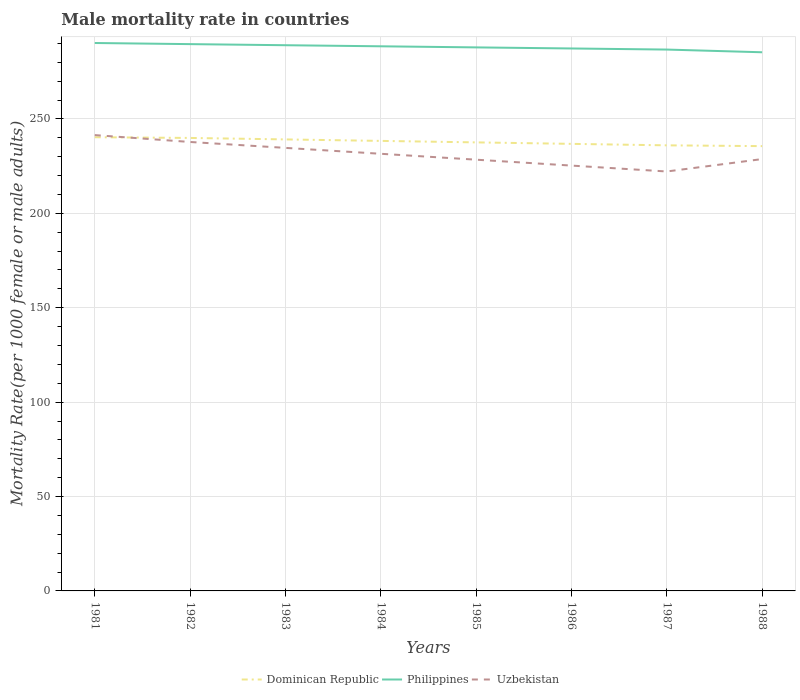How many different coloured lines are there?
Keep it short and to the point. 3. Is the number of lines equal to the number of legend labels?
Keep it short and to the point. Yes. Across all years, what is the maximum male mortality rate in Dominican Republic?
Provide a succinct answer. 235.6. What is the total male mortality rate in Dominican Republic in the graph?
Ensure brevity in your answer.  3.55. What is the difference between the highest and the second highest male mortality rate in Uzbekistan?
Provide a succinct answer. 19.28. Is the male mortality rate in Dominican Republic strictly greater than the male mortality rate in Uzbekistan over the years?
Ensure brevity in your answer.  No. How many lines are there?
Your answer should be very brief. 3. How many years are there in the graph?
Give a very brief answer. 8. Does the graph contain any zero values?
Keep it short and to the point. No. Does the graph contain grids?
Your response must be concise. Yes. How many legend labels are there?
Keep it short and to the point. 3. How are the legend labels stacked?
Your answer should be very brief. Horizontal. What is the title of the graph?
Give a very brief answer. Male mortality rate in countries. Does "Mauritania" appear as one of the legend labels in the graph?
Provide a short and direct response. No. What is the label or title of the X-axis?
Ensure brevity in your answer.  Years. What is the label or title of the Y-axis?
Offer a terse response. Mortality Rate(per 1000 female or male adults). What is the Mortality Rate(per 1000 female or male adults) in Dominican Republic in 1981?
Give a very brief answer. 240.32. What is the Mortality Rate(per 1000 female or male adults) of Philippines in 1981?
Provide a short and direct response. 290.23. What is the Mortality Rate(per 1000 female or male adults) in Uzbekistan in 1981?
Offer a very short reply. 241.45. What is the Mortality Rate(per 1000 female or male adults) in Dominican Republic in 1982?
Give a very brief answer. 239.94. What is the Mortality Rate(per 1000 female or male adults) of Philippines in 1982?
Offer a terse response. 289.63. What is the Mortality Rate(per 1000 female or male adults) of Uzbekistan in 1982?
Keep it short and to the point. 237.8. What is the Mortality Rate(per 1000 female or male adults) of Dominican Republic in 1983?
Offer a very short reply. 239.16. What is the Mortality Rate(per 1000 female or male adults) of Philippines in 1983?
Offer a very short reply. 289.06. What is the Mortality Rate(per 1000 female or male adults) in Uzbekistan in 1983?
Ensure brevity in your answer.  234.68. What is the Mortality Rate(per 1000 female or male adults) of Dominican Republic in 1984?
Give a very brief answer. 238.37. What is the Mortality Rate(per 1000 female or male adults) in Philippines in 1984?
Offer a very short reply. 288.48. What is the Mortality Rate(per 1000 female or male adults) of Uzbekistan in 1984?
Make the answer very short. 231.55. What is the Mortality Rate(per 1000 female or male adults) in Dominican Republic in 1985?
Your response must be concise. 237.59. What is the Mortality Rate(per 1000 female or male adults) in Philippines in 1985?
Give a very brief answer. 287.91. What is the Mortality Rate(per 1000 female or male adults) in Uzbekistan in 1985?
Provide a short and direct response. 228.42. What is the Mortality Rate(per 1000 female or male adults) in Dominican Republic in 1986?
Your answer should be very brief. 236.81. What is the Mortality Rate(per 1000 female or male adults) in Philippines in 1986?
Keep it short and to the point. 287.33. What is the Mortality Rate(per 1000 female or male adults) in Uzbekistan in 1986?
Offer a terse response. 225.3. What is the Mortality Rate(per 1000 female or male adults) of Dominican Republic in 1987?
Provide a short and direct response. 236.02. What is the Mortality Rate(per 1000 female or male adults) of Philippines in 1987?
Ensure brevity in your answer.  286.76. What is the Mortality Rate(per 1000 female or male adults) of Uzbekistan in 1987?
Your answer should be compact. 222.17. What is the Mortality Rate(per 1000 female or male adults) of Dominican Republic in 1988?
Your response must be concise. 235.6. What is the Mortality Rate(per 1000 female or male adults) of Philippines in 1988?
Provide a short and direct response. 285.32. What is the Mortality Rate(per 1000 female or male adults) of Uzbekistan in 1988?
Give a very brief answer. 228.75. Across all years, what is the maximum Mortality Rate(per 1000 female or male adults) of Dominican Republic?
Offer a terse response. 240.32. Across all years, what is the maximum Mortality Rate(per 1000 female or male adults) of Philippines?
Give a very brief answer. 290.23. Across all years, what is the maximum Mortality Rate(per 1000 female or male adults) of Uzbekistan?
Make the answer very short. 241.45. Across all years, what is the minimum Mortality Rate(per 1000 female or male adults) of Dominican Republic?
Offer a terse response. 235.6. Across all years, what is the minimum Mortality Rate(per 1000 female or male adults) of Philippines?
Your answer should be very brief. 285.32. Across all years, what is the minimum Mortality Rate(per 1000 female or male adults) in Uzbekistan?
Offer a terse response. 222.17. What is the total Mortality Rate(per 1000 female or male adults) in Dominican Republic in the graph?
Make the answer very short. 1903.81. What is the total Mortality Rate(per 1000 female or male adults) in Philippines in the graph?
Provide a succinct answer. 2304.71. What is the total Mortality Rate(per 1000 female or male adults) in Uzbekistan in the graph?
Keep it short and to the point. 1850.12. What is the difference between the Mortality Rate(per 1000 female or male adults) of Dominican Republic in 1981 and that in 1982?
Make the answer very short. 0.37. What is the difference between the Mortality Rate(per 1000 female or male adults) in Philippines in 1981 and that in 1982?
Your answer should be compact. 0.6. What is the difference between the Mortality Rate(per 1000 female or male adults) in Uzbekistan in 1981 and that in 1982?
Make the answer very short. 3.65. What is the difference between the Mortality Rate(per 1000 female or male adults) in Dominican Republic in 1981 and that in 1983?
Make the answer very short. 1.16. What is the difference between the Mortality Rate(per 1000 female or male adults) of Philippines in 1981 and that in 1983?
Provide a succinct answer. 1.17. What is the difference between the Mortality Rate(per 1000 female or male adults) in Uzbekistan in 1981 and that in 1983?
Offer a terse response. 6.77. What is the difference between the Mortality Rate(per 1000 female or male adults) of Dominican Republic in 1981 and that in 1984?
Keep it short and to the point. 1.94. What is the difference between the Mortality Rate(per 1000 female or male adults) of Philippines in 1981 and that in 1984?
Provide a short and direct response. 1.75. What is the difference between the Mortality Rate(per 1000 female or male adults) in Uzbekistan in 1981 and that in 1984?
Provide a succinct answer. 9.9. What is the difference between the Mortality Rate(per 1000 female or male adults) in Dominican Republic in 1981 and that in 1985?
Keep it short and to the point. 2.73. What is the difference between the Mortality Rate(per 1000 female or male adults) in Philippines in 1981 and that in 1985?
Give a very brief answer. 2.32. What is the difference between the Mortality Rate(per 1000 female or male adults) in Uzbekistan in 1981 and that in 1985?
Provide a short and direct response. 13.02. What is the difference between the Mortality Rate(per 1000 female or male adults) of Dominican Republic in 1981 and that in 1986?
Keep it short and to the point. 3.51. What is the difference between the Mortality Rate(per 1000 female or male adults) in Philippines in 1981 and that in 1986?
Your answer should be compact. 2.9. What is the difference between the Mortality Rate(per 1000 female or male adults) in Uzbekistan in 1981 and that in 1986?
Offer a very short reply. 16.15. What is the difference between the Mortality Rate(per 1000 female or male adults) of Dominican Republic in 1981 and that in 1987?
Make the answer very short. 4.29. What is the difference between the Mortality Rate(per 1000 female or male adults) in Philippines in 1981 and that in 1987?
Provide a succinct answer. 3.47. What is the difference between the Mortality Rate(per 1000 female or male adults) of Uzbekistan in 1981 and that in 1987?
Your answer should be compact. 19.27. What is the difference between the Mortality Rate(per 1000 female or male adults) in Dominican Republic in 1981 and that in 1988?
Your answer should be compact. 4.71. What is the difference between the Mortality Rate(per 1000 female or male adults) in Philippines in 1981 and that in 1988?
Offer a terse response. 4.91. What is the difference between the Mortality Rate(per 1000 female or male adults) in Uzbekistan in 1981 and that in 1988?
Your answer should be very brief. 12.7. What is the difference between the Mortality Rate(per 1000 female or male adults) in Dominican Republic in 1982 and that in 1983?
Your answer should be compact. 0.78. What is the difference between the Mortality Rate(per 1000 female or male adults) in Philippines in 1982 and that in 1983?
Offer a very short reply. 0.57. What is the difference between the Mortality Rate(per 1000 female or male adults) in Uzbekistan in 1982 and that in 1983?
Your answer should be very brief. 3.13. What is the difference between the Mortality Rate(per 1000 female or male adults) of Dominican Republic in 1982 and that in 1984?
Keep it short and to the point. 1.57. What is the difference between the Mortality Rate(per 1000 female or male adults) of Philippines in 1982 and that in 1984?
Your answer should be very brief. 1.15. What is the difference between the Mortality Rate(per 1000 female or male adults) of Uzbekistan in 1982 and that in 1984?
Make the answer very short. 6.25. What is the difference between the Mortality Rate(per 1000 female or male adults) in Dominican Republic in 1982 and that in 1985?
Make the answer very short. 2.35. What is the difference between the Mortality Rate(per 1000 female or male adults) of Philippines in 1982 and that in 1985?
Ensure brevity in your answer.  1.72. What is the difference between the Mortality Rate(per 1000 female or male adults) in Uzbekistan in 1982 and that in 1985?
Ensure brevity in your answer.  9.38. What is the difference between the Mortality Rate(per 1000 female or male adults) in Dominican Republic in 1982 and that in 1986?
Ensure brevity in your answer.  3.13. What is the difference between the Mortality Rate(per 1000 female or male adults) of Philippines in 1982 and that in 1986?
Keep it short and to the point. 2.3. What is the difference between the Mortality Rate(per 1000 female or male adults) of Uzbekistan in 1982 and that in 1986?
Keep it short and to the point. 12.5. What is the difference between the Mortality Rate(per 1000 female or male adults) in Dominican Republic in 1982 and that in 1987?
Give a very brief answer. 3.92. What is the difference between the Mortality Rate(per 1000 female or male adults) in Philippines in 1982 and that in 1987?
Offer a terse response. 2.87. What is the difference between the Mortality Rate(per 1000 female or male adults) in Uzbekistan in 1982 and that in 1987?
Your answer should be compact. 15.63. What is the difference between the Mortality Rate(per 1000 female or male adults) of Dominican Republic in 1982 and that in 1988?
Offer a terse response. 4.34. What is the difference between the Mortality Rate(per 1000 female or male adults) in Philippines in 1982 and that in 1988?
Give a very brief answer. 4.31. What is the difference between the Mortality Rate(per 1000 female or male adults) of Uzbekistan in 1982 and that in 1988?
Give a very brief answer. 9.05. What is the difference between the Mortality Rate(per 1000 female or male adults) in Dominican Republic in 1983 and that in 1984?
Make the answer very short. 0.78. What is the difference between the Mortality Rate(per 1000 female or male adults) of Philippines in 1983 and that in 1984?
Offer a terse response. 0.57. What is the difference between the Mortality Rate(per 1000 female or male adults) of Uzbekistan in 1983 and that in 1984?
Offer a very short reply. 3.13. What is the difference between the Mortality Rate(per 1000 female or male adults) of Dominican Republic in 1983 and that in 1985?
Ensure brevity in your answer.  1.57. What is the difference between the Mortality Rate(per 1000 female or male adults) in Philippines in 1983 and that in 1985?
Offer a terse response. 1.15. What is the difference between the Mortality Rate(per 1000 female or male adults) of Uzbekistan in 1983 and that in 1985?
Provide a succinct answer. 6.25. What is the difference between the Mortality Rate(per 1000 female or male adults) of Dominican Republic in 1983 and that in 1986?
Keep it short and to the point. 2.35. What is the difference between the Mortality Rate(per 1000 female or male adults) of Philippines in 1983 and that in 1986?
Provide a succinct answer. 1.72. What is the difference between the Mortality Rate(per 1000 female or male adults) in Uzbekistan in 1983 and that in 1986?
Your answer should be very brief. 9.38. What is the difference between the Mortality Rate(per 1000 female or male adults) of Dominican Republic in 1983 and that in 1987?
Keep it short and to the point. 3.13. What is the difference between the Mortality Rate(per 1000 female or male adults) in Philippines in 1983 and that in 1987?
Ensure brevity in your answer.  2.3. What is the difference between the Mortality Rate(per 1000 female or male adults) in Uzbekistan in 1983 and that in 1987?
Keep it short and to the point. 12.5. What is the difference between the Mortality Rate(per 1000 female or male adults) of Dominican Republic in 1983 and that in 1988?
Your response must be concise. 3.56. What is the difference between the Mortality Rate(per 1000 female or male adults) in Philippines in 1983 and that in 1988?
Provide a succinct answer. 3.74. What is the difference between the Mortality Rate(per 1000 female or male adults) of Uzbekistan in 1983 and that in 1988?
Your response must be concise. 5.93. What is the difference between the Mortality Rate(per 1000 female or male adults) of Dominican Republic in 1984 and that in 1985?
Provide a short and direct response. 0.78. What is the difference between the Mortality Rate(per 1000 female or male adults) of Philippines in 1984 and that in 1985?
Keep it short and to the point. 0.57. What is the difference between the Mortality Rate(per 1000 female or male adults) in Uzbekistan in 1984 and that in 1985?
Keep it short and to the point. 3.13. What is the difference between the Mortality Rate(per 1000 female or male adults) of Dominican Republic in 1984 and that in 1986?
Give a very brief answer. 1.57. What is the difference between the Mortality Rate(per 1000 female or male adults) in Philippines in 1984 and that in 1986?
Ensure brevity in your answer.  1.15. What is the difference between the Mortality Rate(per 1000 female or male adults) of Uzbekistan in 1984 and that in 1986?
Ensure brevity in your answer.  6.25. What is the difference between the Mortality Rate(per 1000 female or male adults) in Dominican Republic in 1984 and that in 1987?
Make the answer very short. 2.35. What is the difference between the Mortality Rate(per 1000 female or male adults) in Philippines in 1984 and that in 1987?
Make the answer very short. 1.72. What is the difference between the Mortality Rate(per 1000 female or male adults) of Uzbekistan in 1984 and that in 1987?
Keep it short and to the point. 9.38. What is the difference between the Mortality Rate(per 1000 female or male adults) of Dominican Republic in 1984 and that in 1988?
Give a very brief answer. 2.77. What is the difference between the Mortality Rate(per 1000 female or male adults) in Philippines in 1984 and that in 1988?
Provide a succinct answer. 3.16. What is the difference between the Mortality Rate(per 1000 female or male adults) in Uzbekistan in 1984 and that in 1988?
Offer a very short reply. 2.8. What is the difference between the Mortality Rate(per 1000 female or male adults) of Dominican Republic in 1985 and that in 1986?
Offer a very short reply. 0.78. What is the difference between the Mortality Rate(per 1000 female or male adults) in Philippines in 1985 and that in 1986?
Your answer should be very brief. 0.57. What is the difference between the Mortality Rate(per 1000 female or male adults) in Uzbekistan in 1985 and that in 1986?
Provide a succinct answer. 3.13. What is the difference between the Mortality Rate(per 1000 female or male adults) in Dominican Republic in 1985 and that in 1987?
Provide a succinct answer. 1.57. What is the difference between the Mortality Rate(per 1000 female or male adults) in Philippines in 1985 and that in 1987?
Offer a terse response. 1.15. What is the difference between the Mortality Rate(per 1000 female or male adults) in Uzbekistan in 1985 and that in 1987?
Offer a very short reply. 6.25. What is the difference between the Mortality Rate(per 1000 female or male adults) of Dominican Republic in 1985 and that in 1988?
Provide a short and direct response. 1.99. What is the difference between the Mortality Rate(per 1000 female or male adults) of Philippines in 1985 and that in 1988?
Your answer should be compact. 2.59. What is the difference between the Mortality Rate(per 1000 female or male adults) in Uzbekistan in 1985 and that in 1988?
Offer a very short reply. -0.32. What is the difference between the Mortality Rate(per 1000 female or male adults) in Dominican Republic in 1986 and that in 1987?
Your answer should be compact. 0.78. What is the difference between the Mortality Rate(per 1000 female or male adults) of Philippines in 1986 and that in 1987?
Provide a short and direct response. 0.57. What is the difference between the Mortality Rate(per 1000 female or male adults) of Uzbekistan in 1986 and that in 1987?
Keep it short and to the point. 3.13. What is the difference between the Mortality Rate(per 1000 female or male adults) in Dominican Republic in 1986 and that in 1988?
Ensure brevity in your answer.  1.2. What is the difference between the Mortality Rate(per 1000 female or male adults) of Philippines in 1986 and that in 1988?
Provide a succinct answer. 2.01. What is the difference between the Mortality Rate(per 1000 female or male adults) of Uzbekistan in 1986 and that in 1988?
Provide a short and direct response. -3.45. What is the difference between the Mortality Rate(per 1000 female or male adults) in Dominican Republic in 1987 and that in 1988?
Provide a succinct answer. 0.42. What is the difference between the Mortality Rate(per 1000 female or male adults) in Philippines in 1987 and that in 1988?
Provide a succinct answer. 1.44. What is the difference between the Mortality Rate(per 1000 female or male adults) of Uzbekistan in 1987 and that in 1988?
Your answer should be very brief. -6.58. What is the difference between the Mortality Rate(per 1000 female or male adults) in Dominican Republic in 1981 and the Mortality Rate(per 1000 female or male adults) in Philippines in 1982?
Offer a terse response. -49.31. What is the difference between the Mortality Rate(per 1000 female or male adults) in Dominican Republic in 1981 and the Mortality Rate(per 1000 female or male adults) in Uzbekistan in 1982?
Give a very brief answer. 2.51. What is the difference between the Mortality Rate(per 1000 female or male adults) in Philippines in 1981 and the Mortality Rate(per 1000 female or male adults) in Uzbekistan in 1982?
Your response must be concise. 52.43. What is the difference between the Mortality Rate(per 1000 female or male adults) of Dominican Republic in 1981 and the Mortality Rate(per 1000 female or male adults) of Philippines in 1983?
Offer a very short reply. -48.74. What is the difference between the Mortality Rate(per 1000 female or male adults) of Dominican Republic in 1981 and the Mortality Rate(per 1000 female or male adults) of Uzbekistan in 1983?
Your answer should be compact. 5.64. What is the difference between the Mortality Rate(per 1000 female or male adults) of Philippines in 1981 and the Mortality Rate(per 1000 female or male adults) of Uzbekistan in 1983?
Your response must be concise. 55.55. What is the difference between the Mortality Rate(per 1000 female or male adults) of Dominican Republic in 1981 and the Mortality Rate(per 1000 female or male adults) of Philippines in 1984?
Provide a short and direct response. -48.16. What is the difference between the Mortality Rate(per 1000 female or male adults) of Dominican Republic in 1981 and the Mortality Rate(per 1000 female or male adults) of Uzbekistan in 1984?
Give a very brief answer. 8.77. What is the difference between the Mortality Rate(per 1000 female or male adults) in Philippines in 1981 and the Mortality Rate(per 1000 female or male adults) in Uzbekistan in 1984?
Keep it short and to the point. 58.68. What is the difference between the Mortality Rate(per 1000 female or male adults) in Dominican Republic in 1981 and the Mortality Rate(per 1000 female or male adults) in Philippines in 1985?
Keep it short and to the point. -47.59. What is the difference between the Mortality Rate(per 1000 female or male adults) in Dominican Republic in 1981 and the Mortality Rate(per 1000 female or male adults) in Uzbekistan in 1985?
Your answer should be compact. 11.89. What is the difference between the Mortality Rate(per 1000 female or male adults) of Philippines in 1981 and the Mortality Rate(per 1000 female or male adults) of Uzbekistan in 1985?
Your answer should be compact. 61.81. What is the difference between the Mortality Rate(per 1000 female or male adults) of Dominican Republic in 1981 and the Mortality Rate(per 1000 female or male adults) of Philippines in 1986?
Give a very brief answer. -47.02. What is the difference between the Mortality Rate(per 1000 female or male adults) of Dominican Republic in 1981 and the Mortality Rate(per 1000 female or male adults) of Uzbekistan in 1986?
Keep it short and to the point. 15.02. What is the difference between the Mortality Rate(per 1000 female or male adults) of Philippines in 1981 and the Mortality Rate(per 1000 female or male adults) of Uzbekistan in 1986?
Your response must be concise. 64.93. What is the difference between the Mortality Rate(per 1000 female or male adults) of Dominican Republic in 1981 and the Mortality Rate(per 1000 female or male adults) of Philippines in 1987?
Your answer should be very brief. -46.44. What is the difference between the Mortality Rate(per 1000 female or male adults) of Dominican Republic in 1981 and the Mortality Rate(per 1000 female or male adults) of Uzbekistan in 1987?
Your response must be concise. 18.14. What is the difference between the Mortality Rate(per 1000 female or male adults) in Philippines in 1981 and the Mortality Rate(per 1000 female or male adults) in Uzbekistan in 1987?
Your answer should be very brief. 68.06. What is the difference between the Mortality Rate(per 1000 female or male adults) of Dominican Republic in 1981 and the Mortality Rate(per 1000 female or male adults) of Philippines in 1988?
Offer a terse response. -45. What is the difference between the Mortality Rate(per 1000 female or male adults) in Dominican Republic in 1981 and the Mortality Rate(per 1000 female or male adults) in Uzbekistan in 1988?
Provide a short and direct response. 11.57. What is the difference between the Mortality Rate(per 1000 female or male adults) of Philippines in 1981 and the Mortality Rate(per 1000 female or male adults) of Uzbekistan in 1988?
Your answer should be very brief. 61.48. What is the difference between the Mortality Rate(per 1000 female or male adults) of Dominican Republic in 1982 and the Mortality Rate(per 1000 female or male adults) of Philippines in 1983?
Your response must be concise. -49.11. What is the difference between the Mortality Rate(per 1000 female or male adults) in Dominican Republic in 1982 and the Mortality Rate(per 1000 female or male adults) in Uzbekistan in 1983?
Ensure brevity in your answer.  5.27. What is the difference between the Mortality Rate(per 1000 female or male adults) of Philippines in 1982 and the Mortality Rate(per 1000 female or male adults) of Uzbekistan in 1983?
Your answer should be very brief. 54.95. What is the difference between the Mortality Rate(per 1000 female or male adults) of Dominican Republic in 1982 and the Mortality Rate(per 1000 female or male adults) of Philippines in 1984?
Provide a succinct answer. -48.54. What is the difference between the Mortality Rate(per 1000 female or male adults) in Dominican Republic in 1982 and the Mortality Rate(per 1000 female or male adults) in Uzbekistan in 1984?
Ensure brevity in your answer.  8.39. What is the difference between the Mortality Rate(per 1000 female or male adults) of Philippines in 1982 and the Mortality Rate(per 1000 female or male adults) of Uzbekistan in 1984?
Provide a short and direct response. 58.08. What is the difference between the Mortality Rate(per 1000 female or male adults) of Dominican Republic in 1982 and the Mortality Rate(per 1000 female or male adults) of Philippines in 1985?
Offer a terse response. -47.97. What is the difference between the Mortality Rate(per 1000 female or male adults) in Dominican Republic in 1982 and the Mortality Rate(per 1000 female or male adults) in Uzbekistan in 1985?
Provide a short and direct response. 11.52. What is the difference between the Mortality Rate(per 1000 female or male adults) of Philippines in 1982 and the Mortality Rate(per 1000 female or male adults) of Uzbekistan in 1985?
Provide a short and direct response. 61.21. What is the difference between the Mortality Rate(per 1000 female or male adults) of Dominican Republic in 1982 and the Mortality Rate(per 1000 female or male adults) of Philippines in 1986?
Provide a short and direct response. -47.39. What is the difference between the Mortality Rate(per 1000 female or male adults) of Dominican Republic in 1982 and the Mortality Rate(per 1000 female or male adults) of Uzbekistan in 1986?
Your answer should be compact. 14.64. What is the difference between the Mortality Rate(per 1000 female or male adults) in Philippines in 1982 and the Mortality Rate(per 1000 female or male adults) in Uzbekistan in 1986?
Make the answer very short. 64.33. What is the difference between the Mortality Rate(per 1000 female or male adults) in Dominican Republic in 1982 and the Mortality Rate(per 1000 female or male adults) in Philippines in 1987?
Keep it short and to the point. -46.81. What is the difference between the Mortality Rate(per 1000 female or male adults) in Dominican Republic in 1982 and the Mortality Rate(per 1000 female or male adults) in Uzbekistan in 1987?
Offer a very short reply. 17.77. What is the difference between the Mortality Rate(per 1000 female or male adults) of Philippines in 1982 and the Mortality Rate(per 1000 female or male adults) of Uzbekistan in 1987?
Offer a very short reply. 67.46. What is the difference between the Mortality Rate(per 1000 female or male adults) of Dominican Republic in 1982 and the Mortality Rate(per 1000 female or male adults) of Philippines in 1988?
Your response must be concise. -45.38. What is the difference between the Mortality Rate(per 1000 female or male adults) of Dominican Republic in 1982 and the Mortality Rate(per 1000 female or male adults) of Uzbekistan in 1988?
Keep it short and to the point. 11.2. What is the difference between the Mortality Rate(per 1000 female or male adults) in Philippines in 1982 and the Mortality Rate(per 1000 female or male adults) in Uzbekistan in 1988?
Give a very brief answer. 60.88. What is the difference between the Mortality Rate(per 1000 female or male adults) of Dominican Republic in 1983 and the Mortality Rate(per 1000 female or male adults) of Philippines in 1984?
Offer a very short reply. -49.32. What is the difference between the Mortality Rate(per 1000 female or male adults) in Dominican Republic in 1983 and the Mortality Rate(per 1000 female or male adults) in Uzbekistan in 1984?
Your answer should be very brief. 7.61. What is the difference between the Mortality Rate(per 1000 female or male adults) of Philippines in 1983 and the Mortality Rate(per 1000 female or male adults) of Uzbekistan in 1984?
Offer a terse response. 57.51. What is the difference between the Mortality Rate(per 1000 female or male adults) of Dominican Republic in 1983 and the Mortality Rate(per 1000 female or male adults) of Philippines in 1985?
Your answer should be compact. -48.75. What is the difference between the Mortality Rate(per 1000 female or male adults) of Dominican Republic in 1983 and the Mortality Rate(per 1000 female or male adults) of Uzbekistan in 1985?
Provide a short and direct response. 10.73. What is the difference between the Mortality Rate(per 1000 female or male adults) of Philippines in 1983 and the Mortality Rate(per 1000 female or male adults) of Uzbekistan in 1985?
Provide a succinct answer. 60.63. What is the difference between the Mortality Rate(per 1000 female or male adults) of Dominican Republic in 1983 and the Mortality Rate(per 1000 female or male adults) of Philippines in 1986?
Your answer should be compact. -48.17. What is the difference between the Mortality Rate(per 1000 female or male adults) in Dominican Republic in 1983 and the Mortality Rate(per 1000 female or male adults) in Uzbekistan in 1986?
Give a very brief answer. 13.86. What is the difference between the Mortality Rate(per 1000 female or male adults) of Philippines in 1983 and the Mortality Rate(per 1000 female or male adults) of Uzbekistan in 1986?
Ensure brevity in your answer.  63.76. What is the difference between the Mortality Rate(per 1000 female or male adults) in Dominican Republic in 1983 and the Mortality Rate(per 1000 female or male adults) in Philippines in 1987?
Provide a succinct answer. -47.6. What is the difference between the Mortality Rate(per 1000 female or male adults) in Dominican Republic in 1983 and the Mortality Rate(per 1000 female or male adults) in Uzbekistan in 1987?
Your answer should be compact. 16.99. What is the difference between the Mortality Rate(per 1000 female or male adults) in Philippines in 1983 and the Mortality Rate(per 1000 female or male adults) in Uzbekistan in 1987?
Your answer should be very brief. 66.88. What is the difference between the Mortality Rate(per 1000 female or male adults) in Dominican Republic in 1983 and the Mortality Rate(per 1000 female or male adults) in Philippines in 1988?
Give a very brief answer. -46.16. What is the difference between the Mortality Rate(per 1000 female or male adults) of Dominican Republic in 1983 and the Mortality Rate(per 1000 female or male adults) of Uzbekistan in 1988?
Offer a terse response. 10.41. What is the difference between the Mortality Rate(per 1000 female or male adults) of Philippines in 1983 and the Mortality Rate(per 1000 female or male adults) of Uzbekistan in 1988?
Give a very brief answer. 60.31. What is the difference between the Mortality Rate(per 1000 female or male adults) in Dominican Republic in 1984 and the Mortality Rate(per 1000 female or male adults) in Philippines in 1985?
Ensure brevity in your answer.  -49.53. What is the difference between the Mortality Rate(per 1000 female or male adults) in Dominican Republic in 1984 and the Mortality Rate(per 1000 female or male adults) in Uzbekistan in 1985?
Keep it short and to the point. 9.95. What is the difference between the Mortality Rate(per 1000 female or male adults) in Philippines in 1984 and the Mortality Rate(per 1000 female or male adults) in Uzbekistan in 1985?
Make the answer very short. 60.06. What is the difference between the Mortality Rate(per 1000 female or male adults) in Dominican Republic in 1984 and the Mortality Rate(per 1000 female or male adults) in Philippines in 1986?
Your answer should be compact. -48.96. What is the difference between the Mortality Rate(per 1000 female or male adults) of Dominican Republic in 1984 and the Mortality Rate(per 1000 female or male adults) of Uzbekistan in 1986?
Offer a terse response. 13.08. What is the difference between the Mortality Rate(per 1000 female or male adults) of Philippines in 1984 and the Mortality Rate(per 1000 female or male adults) of Uzbekistan in 1986?
Keep it short and to the point. 63.18. What is the difference between the Mortality Rate(per 1000 female or male adults) in Dominican Republic in 1984 and the Mortality Rate(per 1000 female or male adults) in Philippines in 1987?
Make the answer very short. -48.38. What is the difference between the Mortality Rate(per 1000 female or male adults) of Dominican Republic in 1984 and the Mortality Rate(per 1000 female or male adults) of Uzbekistan in 1987?
Your answer should be very brief. 16.2. What is the difference between the Mortality Rate(per 1000 female or male adults) of Philippines in 1984 and the Mortality Rate(per 1000 female or male adults) of Uzbekistan in 1987?
Your answer should be compact. 66.31. What is the difference between the Mortality Rate(per 1000 female or male adults) in Dominican Republic in 1984 and the Mortality Rate(per 1000 female or male adults) in Philippines in 1988?
Provide a succinct answer. -46.94. What is the difference between the Mortality Rate(per 1000 female or male adults) of Dominican Republic in 1984 and the Mortality Rate(per 1000 female or male adults) of Uzbekistan in 1988?
Provide a short and direct response. 9.63. What is the difference between the Mortality Rate(per 1000 female or male adults) in Philippines in 1984 and the Mortality Rate(per 1000 female or male adults) in Uzbekistan in 1988?
Offer a very short reply. 59.73. What is the difference between the Mortality Rate(per 1000 female or male adults) of Dominican Republic in 1985 and the Mortality Rate(per 1000 female or male adults) of Philippines in 1986?
Your answer should be compact. -49.74. What is the difference between the Mortality Rate(per 1000 female or male adults) of Dominican Republic in 1985 and the Mortality Rate(per 1000 female or male adults) of Uzbekistan in 1986?
Make the answer very short. 12.29. What is the difference between the Mortality Rate(per 1000 female or male adults) of Philippines in 1985 and the Mortality Rate(per 1000 female or male adults) of Uzbekistan in 1986?
Give a very brief answer. 62.61. What is the difference between the Mortality Rate(per 1000 female or male adults) of Dominican Republic in 1985 and the Mortality Rate(per 1000 female or male adults) of Philippines in 1987?
Ensure brevity in your answer.  -49.17. What is the difference between the Mortality Rate(per 1000 female or male adults) of Dominican Republic in 1985 and the Mortality Rate(per 1000 female or male adults) of Uzbekistan in 1987?
Keep it short and to the point. 15.42. What is the difference between the Mortality Rate(per 1000 female or male adults) of Philippines in 1985 and the Mortality Rate(per 1000 female or male adults) of Uzbekistan in 1987?
Give a very brief answer. 65.73. What is the difference between the Mortality Rate(per 1000 female or male adults) in Dominican Republic in 1985 and the Mortality Rate(per 1000 female or male adults) in Philippines in 1988?
Give a very brief answer. -47.73. What is the difference between the Mortality Rate(per 1000 female or male adults) in Dominican Republic in 1985 and the Mortality Rate(per 1000 female or male adults) in Uzbekistan in 1988?
Your answer should be compact. 8.84. What is the difference between the Mortality Rate(per 1000 female or male adults) in Philippines in 1985 and the Mortality Rate(per 1000 female or male adults) in Uzbekistan in 1988?
Provide a succinct answer. 59.16. What is the difference between the Mortality Rate(per 1000 female or male adults) in Dominican Republic in 1986 and the Mortality Rate(per 1000 female or male adults) in Philippines in 1987?
Your answer should be compact. -49.95. What is the difference between the Mortality Rate(per 1000 female or male adults) in Dominican Republic in 1986 and the Mortality Rate(per 1000 female or male adults) in Uzbekistan in 1987?
Provide a short and direct response. 14.63. What is the difference between the Mortality Rate(per 1000 female or male adults) in Philippines in 1986 and the Mortality Rate(per 1000 female or male adults) in Uzbekistan in 1987?
Provide a succinct answer. 65.16. What is the difference between the Mortality Rate(per 1000 female or male adults) of Dominican Republic in 1986 and the Mortality Rate(per 1000 female or male adults) of Philippines in 1988?
Give a very brief answer. -48.51. What is the difference between the Mortality Rate(per 1000 female or male adults) of Dominican Republic in 1986 and the Mortality Rate(per 1000 female or male adults) of Uzbekistan in 1988?
Offer a terse response. 8.06. What is the difference between the Mortality Rate(per 1000 female or male adults) in Philippines in 1986 and the Mortality Rate(per 1000 female or male adults) in Uzbekistan in 1988?
Ensure brevity in your answer.  58.59. What is the difference between the Mortality Rate(per 1000 female or male adults) of Dominican Republic in 1987 and the Mortality Rate(per 1000 female or male adults) of Philippines in 1988?
Your response must be concise. -49.3. What is the difference between the Mortality Rate(per 1000 female or male adults) of Dominican Republic in 1987 and the Mortality Rate(per 1000 female or male adults) of Uzbekistan in 1988?
Offer a very short reply. 7.28. What is the difference between the Mortality Rate(per 1000 female or male adults) in Philippines in 1987 and the Mortality Rate(per 1000 female or male adults) in Uzbekistan in 1988?
Offer a very short reply. 58.01. What is the average Mortality Rate(per 1000 female or male adults) of Dominican Republic per year?
Ensure brevity in your answer.  237.98. What is the average Mortality Rate(per 1000 female or male adults) of Philippines per year?
Provide a succinct answer. 288.09. What is the average Mortality Rate(per 1000 female or male adults) in Uzbekistan per year?
Ensure brevity in your answer.  231.26. In the year 1981, what is the difference between the Mortality Rate(per 1000 female or male adults) in Dominican Republic and Mortality Rate(per 1000 female or male adults) in Philippines?
Provide a succinct answer. -49.91. In the year 1981, what is the difference between the Mortality Rate(per 1000 female or male adults) in Dominican Republic and Mortality Rate(per 1000 female or male adults) in Uzbekistan?
Your response must be concise. -1.13. In the year 1981, what is the difference between the Mortality Rate(per 1000 female or male adults) of Philippines and Mortality Rate(per 1000 female or male adults) of Uzbekistan?
Provide a succinct answer. 48.78. In the year 1982, what is the difference between the Mortality Rate(per 1000 female or male adults) in Dominican Republic and Mortality Rate(per 1000 female or male adults) in Philippines?
Make the answer very short. -49.69. In the year 1982, what is the difference between the Mortality Rate(per 1000 female or male adults) in Dominican Republic and Mortality Rate(per 1000 female or male adults) in Uzbekistan?
Your answer should be compact. 2.14. In the year 1982, what is the difference between the Mortality Rate(per 1000 female or male adults) in Philippines and Mortality Rate(per 1000 female or male adults) in Uzbekistan?
Give a very brief answer. 51.83. In the year 1983, what is the difference between the Mortality Rate(per 1000 female or male adults) in Dominican Republic and Mortality Rate(per 1000 female or male adults) in Philippines?
Make the answer very short. -49.9. In the year 1983, what is the difference between the Mortality Rate(per 1000 female or male adults) of Dominican Republic and Mortality Rate(per 1000 female or male adults) of Uzbekistan?
Offer a very short reply. 4.48. In the year 1983, what is the difference between the Mortality Rate(per 1000 female or male adults) of Philippines and Mortality Rate(per 1000 female or male adults) of Uzbekistan?
Your response must be concise. 54.38. In the year 1984, what is the difference between the Mortality Rate(per 1000 female or male adults) in Dominican Republic and Mortality Rate(per 1000 female or male adults) in Philippines?
Provide a short and direct response. -50.11. In the year 1984, what is the difference between the Mortality Rate(per 1000 female or male adults) in Dominican Republic and Mortality Rate(per 1000 female or male adults) in Uzbekistan?
Give a very brief answer. 6.82. In the year 1984, what is the difference between the Mortality Rate(per 1000 female or male adults) in Philippines and Mortality Rate(per 1000 female or male adults) in Uzbekistan?
Provide a short and direct response. 56.93. In the year 1985, what is the difference between the Mortality Rate(per 1000 female or male adults) in Dominican Republic and Mortality Rate(per 1000 female or male adults) in Philippines?
Your answer should be very brief. -50.32. In the year 1985, what is the difference between the Mortality Rate(per 1000 female or male adults) in Dominican Republic and Mortality Rate(per 1000 female or male adults) in Uzbekistan?
Ensure brevity in your answer.  9.17. In the year 1985, what is the difference between the Mortality Rate(per 1000 female or male adults) of Philippines and Mortality Rate(per 1000 female or male adults) of Uzbekistan?
Provide a succinct answer. 59.48. In the year 1986, what is the difference between the Mortality Rate(per 1000 female or male adults) of Dominican Republic and Mortality Rate(per 1000 female or male adults) of Philippines?
Make the answer very short. -50.52. In the year 1986, what is the difference between the Mortality Rate(per 1000 female or male adults) of Dominican Republic and Mortality Rate(per 1000 female or male adults) of Uzbekistan?
Make the answer very short. 11.51. In the year 1986, what is the difference between the Mortality Rate(per 1000 female or male adults) of Philippines and Mortality Rate(per 1000 female or male adults) of Uzbekistan?
Offer a very short reply. 62.03. In the year 1987, what is the difference between the Mortality Rate(per 1000 female or male adults) in Dominican Republic and Mortality Rate(per 1000 female or male adults) in Philippines?
Make the answer very short. -50.73. In the year 1987, what is the difference between the Mortality Rate(per 1000 female or male adults) of Dominican Republic and Mortality Rate(per 1000 female or male adults) of Uzbekistan?
Provide a short and direct response. 13.85. In the year 1987, what is the difference between the Mortality Rate(per 1000 female or male adults) of Philippines and Mortality Rate(per 1000 female or male adults) of Uzbekistan?
Your answer should be very brief. 64.58. In the year 1988, what is the difference between the Mortality Rate(per 1000 female or male adults) in Dominican Republic and Mortality Rate(per 1000 female or male adults) in Philippines?
Give a very brief answer. -49.72. In the year 1988, what is the difference between the Mortality Rate(per 1000 female or male adults) of Dominican Republic and Mortality Rate(per 1000 female or male adults) of Uzbekistan?
Offer a terse response. 6.86. In the year 1988, what is the difference between the Mortality Rate(per 1000 female or male adults) of Philippines and Mortality Rate(per 1000 female or male adults) of Uzbekistan?
Your response must be concise. 56.57. What is the ratio of the Mortality Rate(per 1000 female or male adults) in Dominican Republic in 1981 to that in 1982?
Make the answer very short. 1. What is the ratio of the Mortality Rate(per 1000 female or male adults) of Uzbekistan in 1981 to that in 1982?
Offer a terse response. 1.02. What is the ratio of the Mortality Rate(per 1000 female or male adults) of Uzbekistan in 1981 to that in 1983?
Ensure brevity in your answer.  1.03. What is the ratio of the Mortality Rate(per 1000 female or male adults) in Uzbekistan in 1981 to that in 1984?
Your answer should be compact. 1.04. What is the ratio of the Mortality Rate(per 1000 female or male adults) in Dominican Republic in 1981 to that in 1985?
Offer a terse response. 1.01. What is the ratio of the Mortality Rate(per 1000 female or male adults) in Philippines in 1981 to that in 1985?
Provide a short and direct response. 1.01. What is the ratio of the Mortality Rate(per 1000 female or male adults) of Uzbekistan in 1981 to that in 1985?
Your answer should be compact. 1.06. What is the ratio of the Mortality Rate(per 1000 female or male adults) in Dominican Republic in 1981 to that in 1986?
Your answer should be very brief. 1.01. What is the ratio of the Mortality Rate(per 1000 female or male adults) in Uzbekistan in 1981 to that in 1986?
Give a very brief answer. 1.07. What is the ratio of the Mortality Rate(per 1000 female or male adults) of Dominican Republic in 1981 to that in 1987?
Offer a terse response. 1.02. What is the ratio of the Mortality Rate(per 1000 female or male adults) of Philippines in 1981 to that in 1987?
Ensure brevity in your answer.  1.01. What is the ratio of the Mortality Rate(per 1000 female or male adults) of Uzbekistan in 1981 to that in 1987?
Your answer should be compact. 1.09. What is the ratio of the Mortality Rate(per 1000 female or male adults) of Dominican Republic in 1981 to that in 1988?
Provide a short and direct response. 1.02. What is the ratio of the Mortality Rate(per 1000 female or male adults) of Philippines in 1981 to that in 1988?
Give a very brief answer. 1.02. What is the ratio of the Mortality Rate(per 1000 female or male adults) of Uzbekistan in 1981 to that in 1988?
Provide a short and direct response. 1.06. What is the ratio of the Mortality Rate(per 1000 female or male adults) in Dominican Republic in 1982 to that in 1983?
Make the answer very short. 1. What is the ratio of the Mortality Rate(per 1000 female or male adults) in Philippines in 1982 to that in 1983?
Provide a succinct answer. 1. What is the ratio of the Mortality Rate(per 1000 female or male adults) in Uzbekistan in 1982 to that in 1983?
Your response must be concise. 1.01. What is the ratio of the Mortality Rate(per 1000 female or male adults) in Dominican Republic in 1982 to that in 1984?
Keep it short and to the point. 1.01. What is the ratio of the Mortality Rate(per 1000 female or male adults) of Dominican Republic in 1982 to that in 1985?
Provide a short and direct response. 1.01. What is the ratio of the Mortality Rate(per 1000 female or male adults) of Uzbekistan in 1982 to that in 1985?
Keep it short and to the point. 1.04. What is the ratio of the Mortality Rate(per 1000 female or male adults) in Dominican Republic in 1982 to that in 1986?
Provide a succinct answer. 1.01. What is the ratio of the Mortality Rate(per 1000 female or male adults) of Philippines in 1982 to that in 1986?
Your answer should be very brief. 1.01. What is the ratio of the Mortality Rate(per 1000 female or male adults) in Uzbekistan in 1982 to that in 1986?
Your response must be concise. 1.06. What is the ratio of the Mortality Rate(per 1000 female or male adults) of Dominican Republic in 1982 to that in 1987?
Your answer should be compact. 1.02. What is the ratio of the Mortality Rate(per 1000 female or male adults) of Philippines in 1982 to that in 1987?
Your answer should be compact. 1.01. What is the ratio of the Mortality Rate(per 1000 female or male adults) in Uzbekistan in 1982 to that in 1987?
Offer a very short reply. 1.07. What is the ratio of the Mortality Rate(per 1000 female or male adults) of Dominican Republic in 1982 to that in 1988?
Keep it short and to the point. 1.02. What is the ratio of the Mortality Rate(per 1000 female or male adults) of Philippines in 1982 to that in 1988?
Ensure brevity in your answer.  1.02. What is the ratio of the Mortality Rate(per 1000 female or male adults) of Uzbekistan in 1982 to that in 1988?
Your response must be concise. 1.04. What is the ratio of the Mortality Rate(per 1000 female or male adults) of Uzbekistan in 1983 to that in 1984?
Your response must be concise. 1.01. What is the ratio of the Mortality Rate(per 1000 female or male adults) of Dominican Republic in 1983 to that in 1985?
Your answer should be very brief. 1.01. What is the ratio of the Mortality Rate(per 1000 female or male adults) in Philippines in 1983 to that in 1985?
Provide a succinct answer. 1. What is the ratio of the Mortality Rate(per 1000 female or male adults) of Uzbekistan in 1983 to that in 1985?
Make the answer very short. 1.03. What is the ratio of the Mortality Rate(per 1000 female or male adults) in Dominican Republic in 1983 to that in 1986?
Make the answer very short. 1.01. What is the ratio of the Mortality Rate(per 1000 female or male adults) in Philippines in 1983 to that in 1986?
Your answer should be very brief. 1.01. What is the ratio of the Mortality Rate(per 1000 female or male adults) in Uzbekistan in 1983 to that in 1986?
Provide a succinct answer. 1.04. What is the ratio of the Mortality Rate(per 1000 female or male adults) in Dominican Republic in 1983 to that in 1987?
Provide a short and direct response. 1.01. What is the ratio of the Mortality Rate(per 1000 female or male adults) in Philippines in 1983 to that in 1987?
Make the answer very short. 1.01. What is the ratio of the Mortality Rate(per 1000 female or male adults) of Uzbekistan in 1983 to that in 1987?
Your answer should be compact. 1.06. What is the ratio of the Mortality Rate(per 1000 female or male adults) in Dominican Republic in 1983 to that in 1988?
Give a very brief answer. 1.02. What is the ratio of the Mortality Rate(per 1000 female or male adults) in Philippines in 1983 to that in 1988?
Provide a short and direct response. 1.01. What is the ratio of the Mortality Rate(per 1000 female or male adults) of Uzbekistan in 1983 to that in 1988?
Your answer should be compact. 1.03. What is the ratio of the Mortality Rate(per 1000 female or male adults) of Philippines in 1984 to that in 1985?
Your answer should be compact. 1. What is the ratio of the Mortality Rate(per 1000 female or male adults) in Uzbekistan in 1984 to that in 1985?
Your answer should be very brief. 1.01. What is the ratio of the Mortality Rate(per 1000 female or male adults) in Dominican Republic in 1984 to that in 1986?
Offer a very short reply. 1.01. What is the ratio of the Mortality Rate(per 1000 female or male adults) in Uzbekistan in 1984 to that in 1986?
Offer a terse response. 1.03. What is the ratio of the Mortality Rate(per 1000 female or male adults) of Uzbekistan in 1984 to that in 1987?
Your response must be concise. 1.04. What is the ratio of the Mortality Rate(per 1000 female or male adults) in Dominican Republic in 1984 to that in 1988?
Your response must be concise. 1.01. What is the ratio of the Mortality Rate(per 1000 female or male adults) of Philippines in 1984 to that in 1988?
Provide a short and direct response. 1.01. What is the ratio of the Mortality Rate(per 1000 female or male adults) in Uzbekistan in 1984 to that in 1988?
Make the answer very short. 1.01. What is the ratio of the Mortality Rate(per 1000 female or male adults) in Uzbekistan in 1985 to that in 1986?
Provide a succinct answer. 1.01. What is the ratio of the Mortality Rate(per 1000 female or male adults) in Dominican Republic in 1985 to that in 1987?
Your answer should be very brief. 1.01. What is the ratio of the Mortality Rate(per 1000 female or male adults) of Uzbekistan in 1985 to that in 1987?
Make the answer very short. 1.03. What is the ratio of the Mortality Rate(per 1000 female or male adults) of Dominican Republic in 1985 to that in 1988?
Offer a very short reply. 1.01. What is the ratio of the Mortality Rate(per 1000 female or male adults) in Philippines in 1985 to that in 1988?
Offer a terse response. 1.01. What is the ratio of the Mortality Rate(per 1000 female or male adults) of Dominican Republic in 1986 to that in 1987?
Offer a terse response. 1. What is the ratio of the Mortality Rate(per 1000 female or male adults) of Philippines in 1986 to that in 1987?
Your answer should be compact. 1. What is the ratio of the Mortality Rate(per 1000 female or male adults) in Uzbekistan in 1986 to that in 1987?
Provide a succinct answer. 1.01. What is the ratio of the Mortality Rate(per 1000 female or male adults) in Philippines in 1986 to that in 1988?
Offer a very short reply. 1.01. What is the ratio of the Mortality Rate(per 1000 female or male adults) of Uzbekistan in 1986 to that in 1988?
Your answer should be compact. 0.98. What is the ratio of the Mortality Rate(per 1000 female or male adults) of Philippines in 1987 to that in 1988?
Your answer should be very brief. 1. What is the ratio of the Mortality Rate(per 1000 female or male adults) of Uzbekistan in 1987 to that in 1988?
Your answer should be very brief. 0.97. What is the difference between the highest and the second highest Mortality Rate(per 1000 female or male adults) in Dominican Republic?
Give a very brief answer. 0.37. What is the difference between the highest and the second highest Mortality Rate(per 1000 female or male adults) of Philippines?
Make the answer very short. 0.6. What is the difference between the highest and the second highest Mortality Rate(per 1000 female or male adults) of Uzbekistan?
Provide a succinct answer. 3.65. What is the difference between the highest and the lowest Mortality Rate(per 1000 female or male adults) in Dominican Republic?
Provide a short and direct response. 4.71. What is the difference between the highest and the lowest Mortality Rate(per 1000 female or male adults) in Philippines?
Keep it short and to the point. 4.91. What is the difference between the highest and the lowest Mortality Rate(per 1000 female or male adults) of Uzbekistan?
Ensure brevity in your answer.  19.27. 